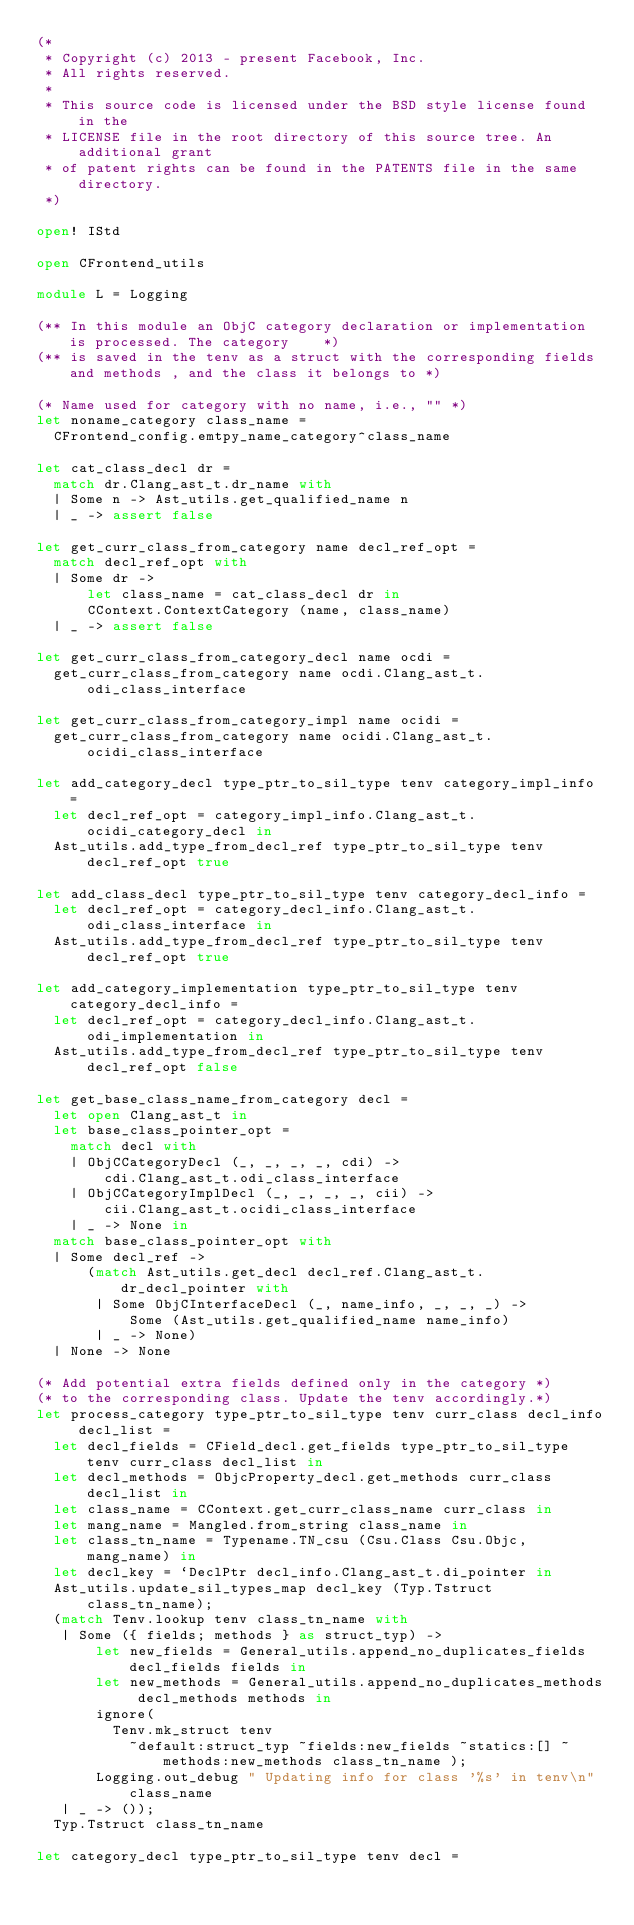<code> <loc_0><loc_0><loc_500><loc_500><_OCaml_>(*
 * Copyright (c) 2013 - present Facebook, Inc.
 * All rights reserved.
 *
 * This source code is licensed under the BSD style license found in the
 * LICENSE file in the root directory of this source tree. An additional grant
 * of patent rights can be found in the PATENTS file in the same directory.
 *)

open! IStd

open CFrontend_utils

module L = Logging

(** In this module an ObjC category declaration or implementation is processed. The category    *)
(** is saved in the tenv as a struct with the corresponding fields and methods , and the class it belongs to *)

(* Name used for category with no name, i.e., "" *)
let noname_category class_name =
  CFrontend_config.emtpy_name_category^class_name

let cat_class_decl dr =
  match dr.Clang_ast_t.dr_name with
  | Some n -> Ast_utils.get_qualified_name n
  | _ -> assert false

let get_curr_class_from_category name decl_ref_opt =
  match decl_ref_opt with
  | Some dr ->
      let class_name = cat_class_decl dr in
      CContext.ContextCategory (name, class_name)
  | _ -> assert false

let get_curr_class_from_category_decl name ocdi =
  get_curr_class_from_category name ocdi.Clang_ast_t.odi_class_interface

let get_curr_class_from_category_impl name ocidi =
  get_curr_class_from_category name ocidi.Clang_ast_t.ocidi_class_interface

let add_category_decl type_ptr_to_sil_type tenv category_impl_info =
  let decl_ref_opt = category_impl_info.Clang_ast_t.ocidi_category_decl in
  Ast_utils.add_type_from_decl_ref type_ptr_to_sil_type tenv decl_ref_opt true

let add_class_decl type_ptr_to_sil_type tenv category_decl_info =
  let decl_ref_opt = category_decl_info.Clang_ast_t.odi_class_interface in
  Ast_utils.add_type_from_decl_ref type_ptr_to_sil_type tenv decl_ref_opt true

let add_category_implementation type_ptr_to_sil_type tenv category_decl_info =
  let decl_ref_opt = category_decl_info.Clang_ast_t.odi_implementation in
  Ast_utils.add_type_from_decl_ref type_ptr_to_sil_type tenv decl_ref_opt false

let get_base_class_name_from_category decl =
  let open Clang_ast_t in
  let base_class_pointer_opt =
    match decl with
    | ObjCCategoryDecl (_, _, _, _, cdi) ->
        cdi.Clang_ast_t.odi_class_interface
    | ObjCCategoryImplDecl (_, _, _, _, cii) ->
        cii.Clang_ast_t.ocidi_class_interface
    | _ -> None in
  match base_class_pointer_opt with
  | Some decl_ref ->
      (match Ast_utils.get_decl decl_ref.Clang_ast_t.dr_decl_pointer with
       | Some ObjCInterfaceDecl (_, name_info, _, _, _) ->
           Some (Ast_utils.get_qualified_name name_info)
       | _ -> None)
  | None -> None

(* Add potential extra fields defined only in the category *)
(* to the corresponding class. Update the tenv accordingly.*)
let process_category type_ptr_to_sil_type tenv curr_class decl_info decl_list =
  let decl_fields = CField_decl.get_fields type_ptr_to_sil_type tenv curr_class decl_list in
  let decl_methods = ObjcProperty_decl.get_methods curr_class decl_list in
  let class_name = CContext.get_curr_class_name curr_class in
  let mang_name = Mangled.from_string class_name in
  let class_tn_name = Typename.TN_csu (Csu.Class Csu.Objc, mang_name) in
  let decl_key = `DeclPtr decl_info.Clang_ast_t.di_pointer in
  Ast_utils.update_sil_types_map decl_key (Typ.Tstruct class_tn_name);
  (match Tenv.lookup tenv class_tn_name with
   | Some ({ fields; methods } as struct_typ) ->
       let new_fields = General_utils.append_no_duplicates_fields decl_fields fields in
       let new_methods = General_utils.append_no_duplicates_methods decl_methods methods in
       ignore(
         Tenv.mk_struct tenv
           ~default:struct_typ ~fields:new_fields ~statics:[] ~methods:new_methods class_tn_name );
       Logging.out_debug " Updating info for class '%s' in tenv\n" class_name
   | _ -> ());
  Typ.Tstruct class_tn_name

let category_decl type_ptr_to_sil_type tenv decl =</code> 